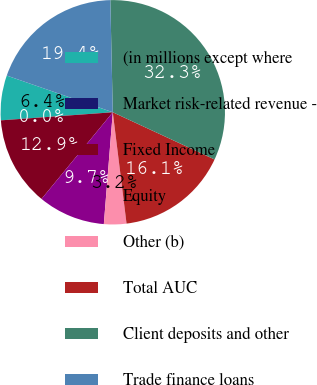<chart> <loc_0><loc_0><loc_500><loc_500><pie_chart><fcel>(in millions except where<fcel>Market risk-related revenue -<fcel>Fixed Income<fcel>Equity<fcel>Other (b)<fcel>Total AUC<fcel>Client deposits and other<fcel>Trade finance loans<nl><fcel>6.45%<fcel>0.0%<fcel>12.9%<fcel>9.68%<fcel>3.23%<fcel>16.13%<fcel>32.26%<fcel>19.35%<nl></chart> 